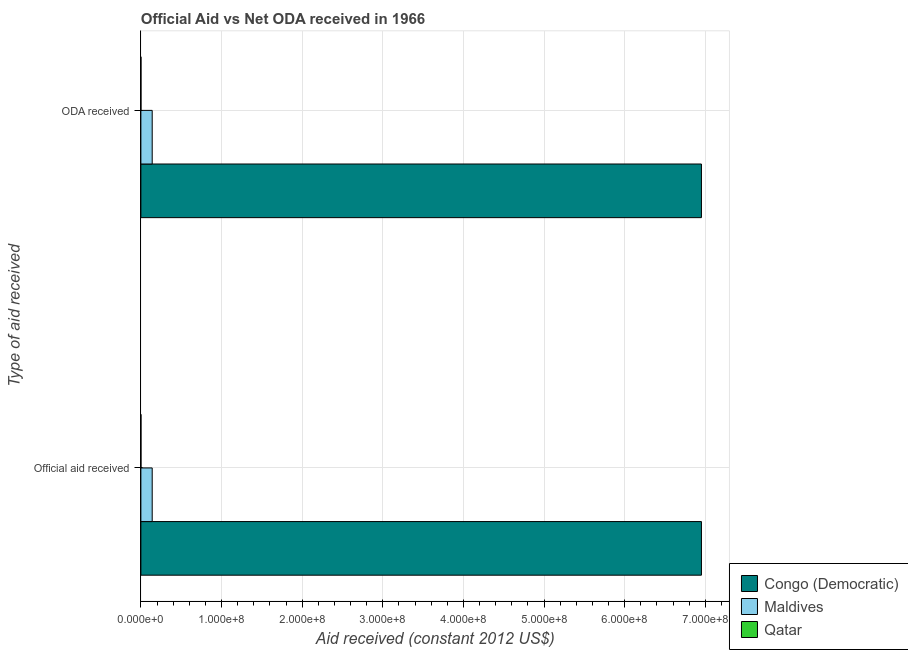How many groups of bars are there?
Offer a very short reply. 2. Are the number of bars on each tick of the Y-axis equal?
Your response must be concise. Yes. What is the label of the 2nd group of bars from the top?
Offer a very short reply. Official aid received. What is the official aid received in Congo (Democratic)?
Your response must be concise. 6.95e+08. Across all countries, what is the maximum official aid received?
Provide a short and direct response. 6.95e+08. Across all countries, what is the minimum oda received?
Ensure brevity in your answer.  7.00e+04. In which country was the oda received maximum?
Offer a very short reply. Congo (Democratic). In which country was the official aid received minimum?
Provide a short and direct response. Qatar. What is the total official aid received in the graph?
Your answer should be very brief. 7.09e+08. What is the difference between the official aid received in Congo (Democratic) and that in Maldives?
Provide a succinct answer. 6.81e+08. What is the difference between the official aid received in Qatar and the oda received in Maldives?
Give a very brief answer. -1.40e+07. What is the average oda received per country?
Give a very brief answer. 2.36e+08. What is the difference between the official aid received and oda received in Maldives?
Provide a short and direct response. 0. What is the ratio of the oda received in Qatar to that in Congo (Democratic)?
Give a very brief answer. 0. What does the 2nd bar from the top in Official aid received represents?
Your answer should be compact. Maldives. What does the 2nd bar from the bottom in Official aid received represents?
Your answer should be compact. Maldives. How many bars are there?
Your answer should be very brief. 6. Are all the bars in the graph horizontal?
Your answer should be very brief. Yes. How many countries are there in the graph?
Offer a terse response. 3. Are the values on the major ticks of X-axis written in scientific E-notation?
Give a very brief answer. Yes. Does the graph contain any zero values?
Keep it short and to the point. No. Does the graph contain grids?
Your response must be concise. Yes. How many legend labels are there?
Offer a terse response. 3. What is the title of the graph?
Your answer should be very brief. Official Aid vs Net ODA received in 1966 . What is the label or title of the X-axis?
Your response must be concise. Aid received (constant 2012 US$). What is the label or title of the Y-axis?
Give a very brief answer. Type of aid received. What is the Aid received (constant 2012 US$) in Congo (Democratic) in Official aid received?
Give a very brief answer. 6.95e+08. What is the Aid received (constant 2012 US$) in Maldives in Official aid received?
Keep it short and to the point. 1.40e+07. What is the Aid received (constant 2012 US$) in Qatar in Official aid received?
Your answer should be compact. 7.00e+04. What is the Aid received (constant 2012 US$) of Congo (Democratic) in ODA received?
Keep it short and to the point. 6.95e+08. What is the Aid received (constant 2012 US$) in Maldives in ODA received?
Make the answer very short. 1.40e+07. Across all Type of aid received, what is the maximum Aid received (constant 2012 US$) of Congo (Democratic)?
Your answer should be very brief. 6.95e+08. Across all Type of aid received, what is the maximum Aid received (constant 2012 US$) of Maldives?
Your response must be concise. 1.40e+07. Across all Type of aid received, what is the minimum Aid received (constant 2012 US$) of Congo (Democratic)?
Provide a succinct answer. 6.95e+08. Across all Type of aid received, what is the minimum Aid received (constant 2012 US$) in Maldives?
Your answer should be compact. 1.40e+07. Across all Type of aid received, what is the minimum Aid received (constant 2012 US$) of Qatar?
Your answer should be compact. 7.00e+04. What is the total Aid received (constant 2012 US$) of Congo (Democratic) in the graph?
Keep it short and to the point. 1.39e+09. What is the total Aid received (constant 2012 US$) of Maldives in the graph?
Provide a short and direct response. 2.81e+07. What is the difference between the Aid received (constant 2012 US$) in Maldives in Official aid received and that in ODA received?
Offer a terse response. 0. What is the difference between the Aid received (constant 2012 US$) in Qatar in Official aid received and that in ODA received?
Make the answer very short. 0. What is the difference between the Aid received (constant 2012 US$) in Congo (Democratic) in Official aid received and the Aid received (constant 2012 US$) in Maldives in ODA received?
Make the answer very short. 6.81e+08. What is the difference between the Aid received (constant 2012 US$) in Congo (Democratic) in Official aid received and the Aid received (constant 2012 US$) in Qatar in ODA received?
Your answer should be compact. 6.95e+08. What is the difference between the Aid received (constant 2012 US$) in Maldives in Official aid received and the Aid received (constant 2012 US$) in Qatar in ODA received?
Offer a terse response. 1.40e+07. What is the average Aid received (constant 2012 US$) in Congo (Democratic) per Type of aid received?
Provide a succinct answer. 6.95e+08. What is the average Aid received (constant 2012 US$) of Maldives per Type of aid received?
Your answer should be very brief. 1.40e+07. What is the average Aid received (constant 2012 US$) of Qatar per Type of aid received?
Offer a very short reply. 7.00e+04. What is the difference between the Aid received (constant 2012 US$) in Congo (Democratic) and Aid received (constant 2012 US$) in Maldives in Official aid received?
Your answer should be very brief. 6.81e+08. What is the difference between the Aid received (constant 2012 US$) of Congo (Democratic) and Aid received (constant 2012 US$) of Qatar in Official aid received?
Make the answer very short. 6.95e+08. What is the difference between the Aid received (constant 2012 US$) of Maldives and Aid received (constant 2012 US$) of Qatar in Official aid received?
Provide a succinct answer. 1.40e+07. What is the difference between the Aid received (constant 2012 US$) of Congo (Democratic) and Aid received (constant 2012 US$) of Maldives in ODA received?
Offer a very short reply. 6.81e+08. What is the difference between the Aid received (constant 2012 US$) of Congo (Democratic) and Aid received (constant 2012 US$) of Qatar in ODA received?
Offer a terse response. 6.95e+08. What is the difference between the Aid received (constant 2012 US$) in Maldives and Aid received (constant 2012 US$) in Qatar in ODA received?
Offer a terse response. 1.40e+07. What is the ratio of the Aid received (constant 2012 US$) in Congo (Democratic) in Official aid received to that in ODA received?
Provide a short and direct response. 1. What is the ratio of the Aid received (constant 2012 US$) of Maldives in Official aid received to that in ODA received?
Make the answer very short. 1. What is the difference between the highest and the second highest Aid received (constant 2012 US$) in Qatar?
Provide a succinct answer. 0. What is the difference between the highest and the lowest Aid received (constant 2012 US$) of Maldives?
Make the answer very short. 0. 